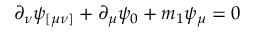<formula> <loc_0><loc_0><loc_500><loc_500>\partial _ { \nu } \psi _ { [ \mu \nu ] } + \partial _ { \mu } \psi _ { 0 } + m _ { 1 } \psi _ { \mu } = 0</formula> 